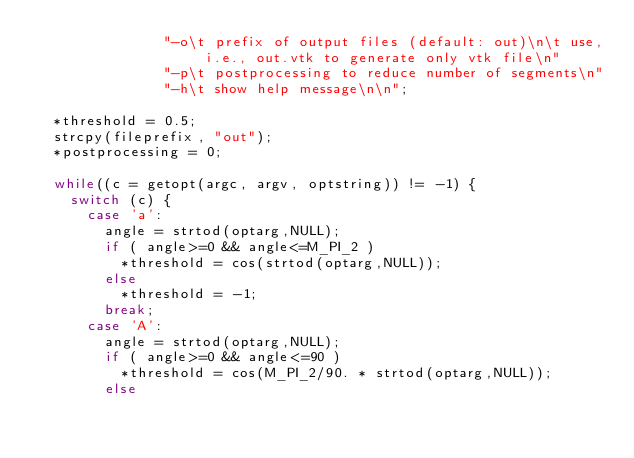<code> <loc_0><loc_0><loc_500><loc_500><_C_>               "-o\t prefix of output files (default: out)\n\t use, i.e., out.vtk to generate only vtk file\n"
               "-p\t postprocessing to reduce number of segments\n"
               "-h\t show help message\n\n";

  *threshold = 0.5;
  strcpy(fileprefix, "out");
  *postprocessing = 0;
  
  while((c = getopt(argc, argv, optstring)) != -1) {
    switch (c) {
      case 'a': 
        angle = strtod(optarg,NULL); 
        if ( angle>=0 && angle<=M_PI_2 )
          *threshold = cos(strtod(optarg,NULL)); 
        else 
          *threshold = -1;
        break;
      case 'A': 
        angle = strtod(optarg,NULL); 
        if ( angle>=0 && angle<=90 )
          *threshold = cos(M_PI_2/90. * strtod(optarg,NULL)); 
        else </code> 